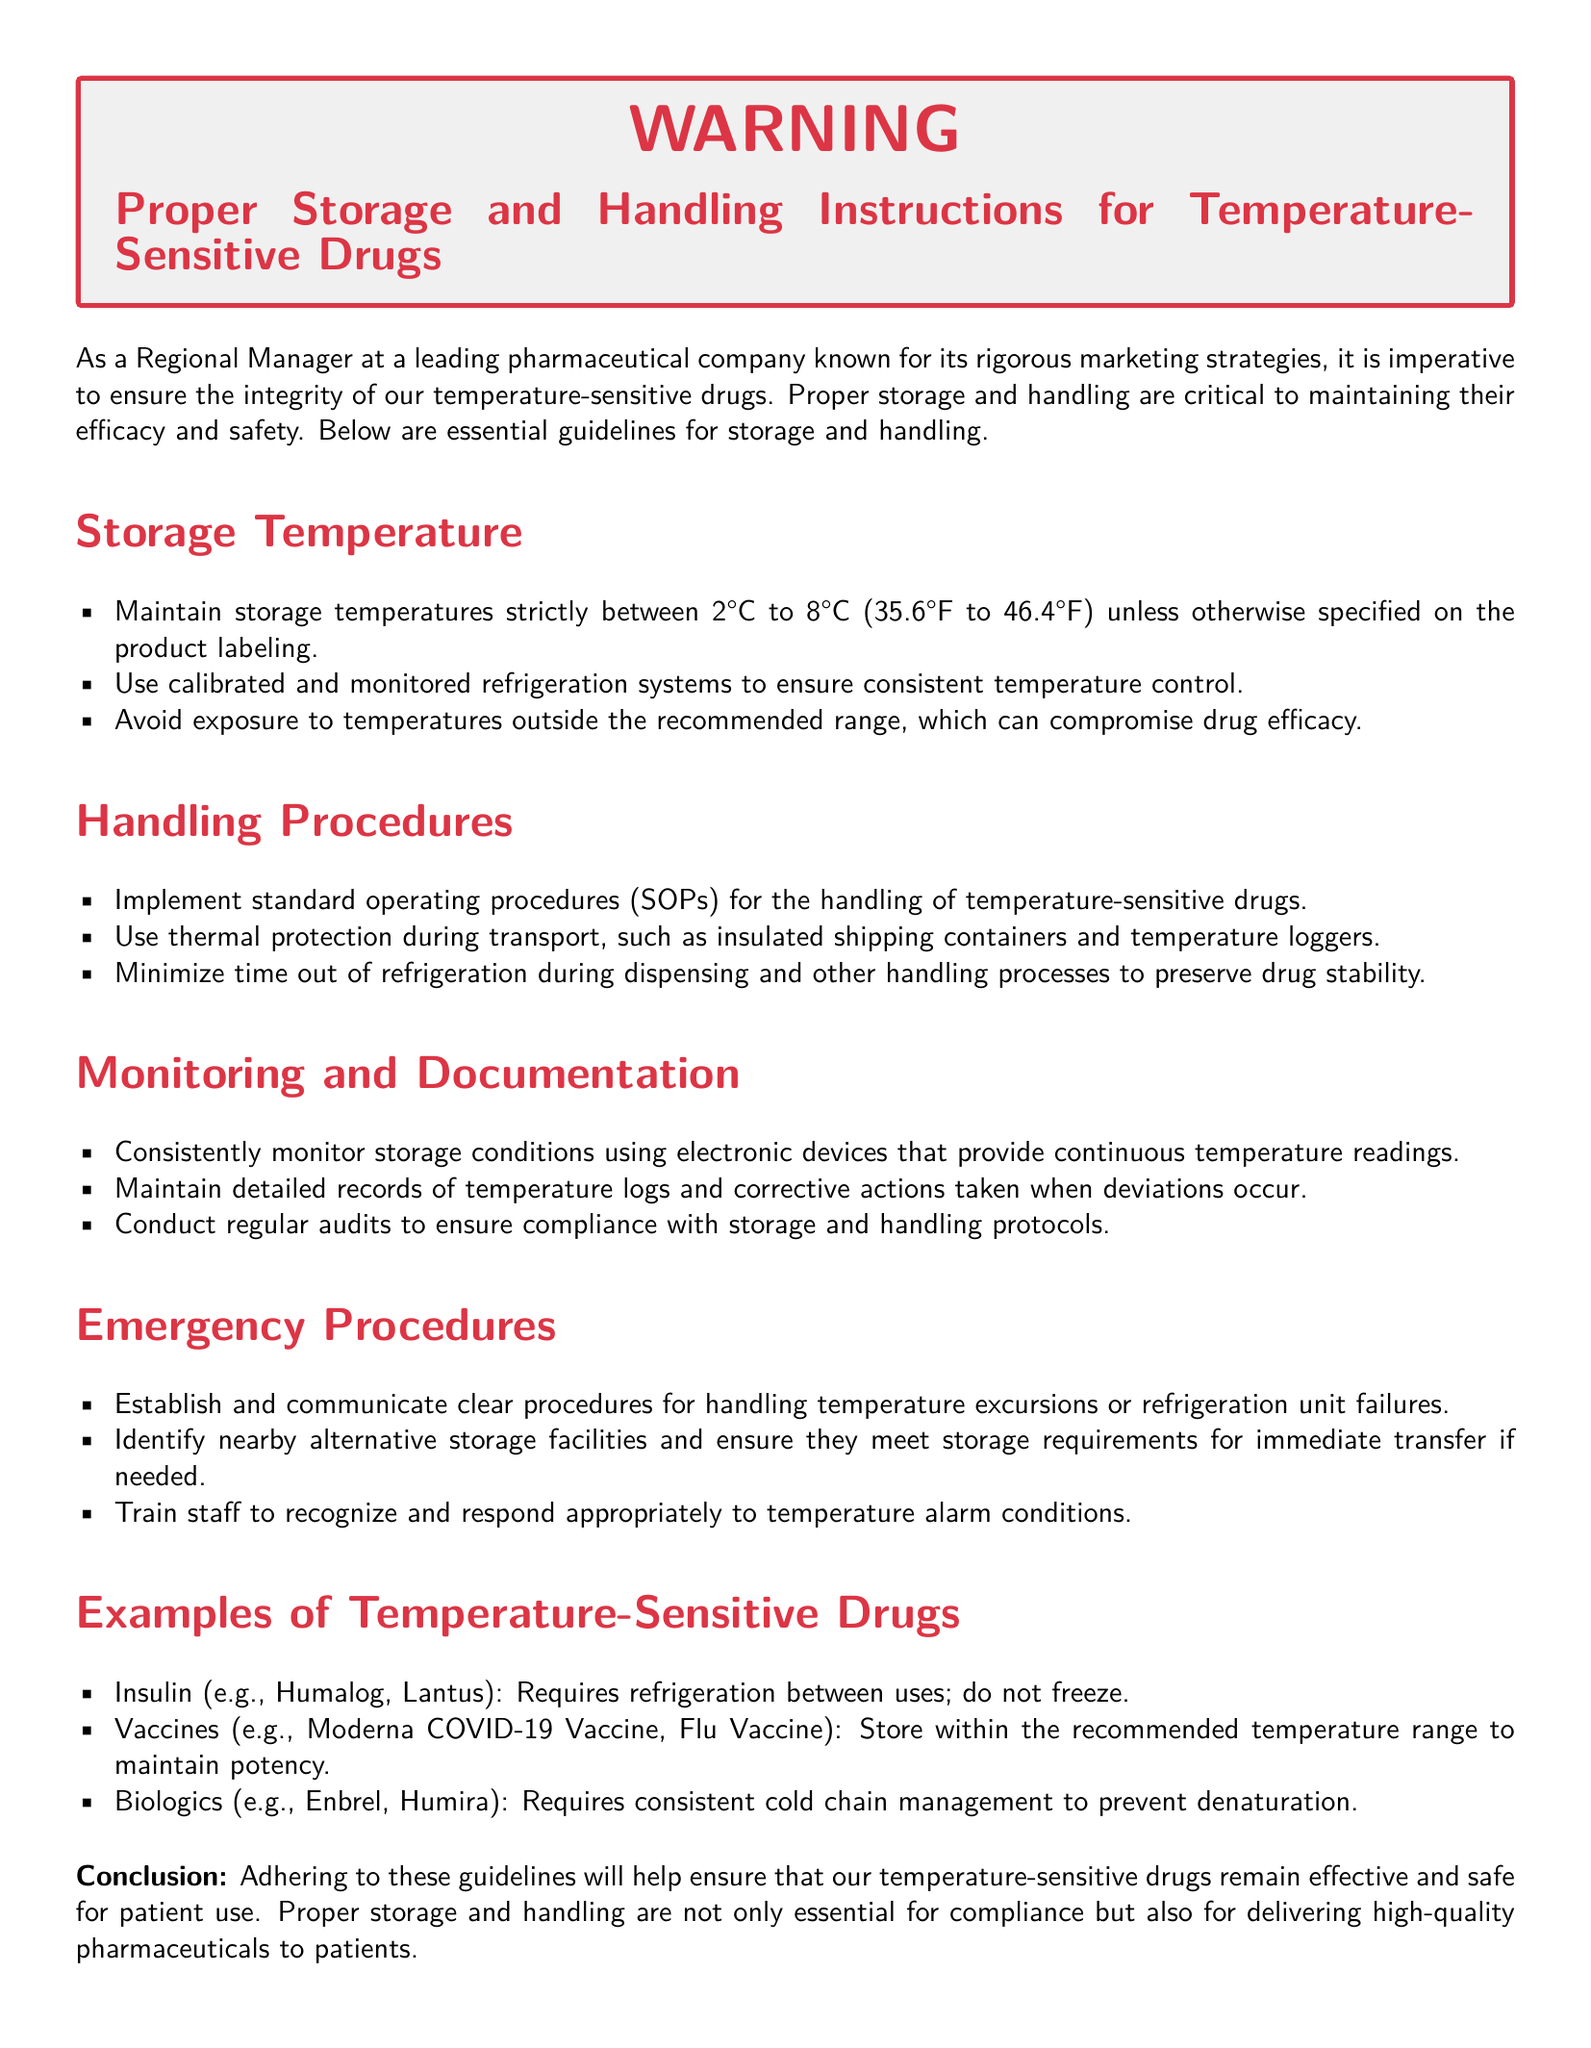What is the recommended storage temperature range for temperature-sensitive drugs? The recommended storage temperature range is specified as between 2°C to 8°C unless otherwise stated.
Answer: 2°C to 8°C What should be used during transport of temperature-sensitive drugs? The document states to use thermal protection such as insulated shipping containers and temperature loggers.
Answer: Insulated shipping containers and temperature loggers What devices should be used to monitor storage conditions? It mentions using electronic devices that provide continuous temperature readings for monitoring storage conditions.
Answer: Electronic devices Which drug example requires refrigeration between uses? Insulin is provided as an example that requires refrigeration between uses.
Answer: Insulin What must staff be trained to recognize in the context of emergency procedures? The document specifies that staff should be trained to recognize temperature alarm conditions.
Answer: Temperature alarm conditions What is essential for maintaining the efficacy and safety of temperature-sensitive drugs? The document emphasizes that proper storage and handling are critical.
Answer: Proper storage and handling What type of procedures should be implemented for handling temperature-sensitive drugs? Standard operating procedures (SOPs) are stated to be implemented for handling temperature-sensitive drugs.
Answer: Standard operating procedures (SOPs) What should be maintained to document temperature stability? Detailed records of temperature logs and corrective actions taken should be maintained according to the document.
Answer: Temperature logs and corrective actions What should be established for handling refrigeration unit failures? The document advises establishing clear procedures for handling temperature excursions or refrigeration unit failures.
Answer: Clear procedures 